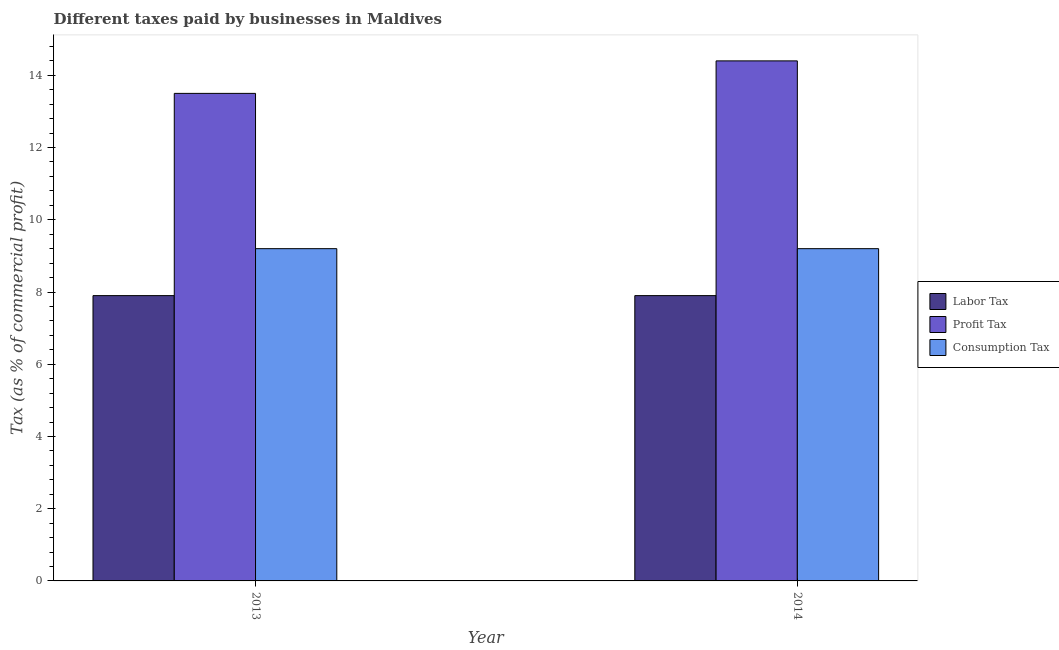How many groups of bars are there?
Your answer should be very brief. 2. How many bars are there on the 1st tick from the right?
Make the answer very short. 3. What is the label of the 2nd group of bars from the left?
Provide a short and direct response. 2014. In how many cases, is the number of bars for a given year not equal to the number of legend labels?
Provide a short and direct response. 0. What is the percentage of labor tax in 2013?
Give a very brief answer. 7.9. Across all years, what is the maximum percentage of consumption tax?
Your answer should be compact. 9.2. Across all years, what is the minimum percentage of consumption tax?
Keep it short and to the point. 9.2. In which year was the percentage of consumption tax maximum?
Offer a terse response. 2013. In which year was the percentage of labor tax minimum?
Keep it short and to the point. 2013. What is the difference between the percentage of profit tax in 2013 and that in 2014?
Offer a terse response. -0.9. What is the difference between the percentage of profit tax in 2014 and the percentage of consumption tax in 2013?
Your answer should be compact. 0.9. What is the average percentage of consumption tax per year?
Offer a very short reply. 9.2. In how many years, is the percentage of labor tax greater than 12.4 %?
Provide a short and direct response. 0. What is the ratio of the percentage of labor tax in 2013 to that in 2014?
Provide a succinct answer. 1. What does the 2nd bar from the left in 2014 represents?
Your response must be concise. Profit Tax. What does the 3rd bar from the right in 2013 represents?
Ensure brevity in your answer.  Labor Tax. Is it the case that in every year, the sum of the percentage of labor tax and percentage of profit tax is greater than the percentage of consumption tax?
Your response must be concise. Yes. Are all the bars in the graph horizontal?
Provide a short and direct response. No. How many years are there in the graph?
Provide a short and direct response. 2. Are the values on the major ticks of Y-axis written in scientific E-notation?
Keep it short and to the point. No. Does the graph contain grids?
Your answer should be compact. No. Where does the legend appear in the graph?
Keep it short and to the point. Center right. How many legend labels are there?
Give a very brief answer. 3. How are the legend labels stacked?
Your answer should be compact. Vertical. What is the title of the graph?
Your response must be concise. Different taxes paid by businesses in Maldives. Does "Labor Market" appear as one of the legend labels in the graph?
Provide a short and direct response. No. What is the label or title of the X-axis?
Your answer should be very brief. Year. What is the label or title of the Y-axis?
Provide a short and direct response. Tax (as % of commercial profit). What is the Tax (as % of commercial profit) in Profit Tax in 2013?
Your answer should be compact. 13.5. What is the Tax (as % of commercial profit) in Consumption Tax in 2013?
Your response must be concise. 9.2. What is the Tax (as % of commercial profit) of Labor Tax in 2014?
Your answer should be very brief. 7.9. What is the Tax (as % of commercial profit) in Profit Tax in 2014?
Your response must be concise. 14.4. What is the Tax (as % of commercial profit) of Consumption Tax in 2014?
Your answer should be very brief. 9.2. Across all years, what is the maximum Tax (as % of commercial profit) in Profit Tax?
Offer a terse response. 14.4. Across all years, what is the minimum Tax (as % of commercial profit) in Labor Tax?
Your answer should be very brief. 7.9. Across all years, what is the minimum Tax (as % of commercial profit) in Profit Tax?
Make the answer very short. 13.5. What is the total Tax (as % of commercial profit) in Labor Tax in the graph?
Your response must be concise. 15.8. What is the total Tax (as % of commercial profit) in Profit Tax in the graph?
Give a very brief answer. 27.9. What is the total Tax (as % of commercial profit) of Consumption Tax in the graph?
Your answer should be very brief. 18.4. What is the difference between the Tax (as % of commercial profit) in Profit Tax in 2013 and that in 2014?
Your answer should be very brief. -0.9. What is the difference between the Tax (as % of commercial profit) of Labor Tax in 2013 and the Tax (as % of commercial profit) of Profit Tax in 2014?
Offer a very short reply. -6.5. What is the difference between the Tax (as % of commercial profit) in Profit Tax in 2013 and the Tax (as % of commercial profit) in Consumption Tax in 2014?
Your answer should be compact. 4.3. What is the average Tax (as % of commercial profit) of Profit Tax per year?
Offer a very short reply. 13.95. In the year 2013, what is the difference between the Tax (as % of commercial profit) in Labor Tax and Tax (as % of commercial profit) in Profit Tax?
Keep it short and to the point. -5.6. In the year 2013, what is the difference between the Tax (as % of commercial profit) of Labor Tax and Tax (as % of commercial profit) of Consumption Tax?
Make the answer very short. -1.3. In the year 2013, what is the difference between the Tax (as % of commercial profit) in Profit Tax and Tax (as % of commercial profit) in Consumption Tax?
Your answer should be compact. 4.3. In the year 2014, what is the difference between the Tax (as % of commercial profit) in Labor Tax and Tax (as % of commercial profit) in Profit Tax?
Offer a terse response. -6.5. In the year 2014, what is the difference between the Tax (as % of commercial profit) of Labor Tax and Tax (as % of commercial profit) of Consumption Tax?
Give a very brief answer. -1.3. In the year 2014, what is the difference between the Tax (as % of commercial profit) in Profit Tax and Tax (as % of commercial profit) in Consumption Tax?
Provide a succinct answer. 5.2. What is the ratio of the Tax (as % of commercial profit) in Labor Tax in 2013 to that in 2014?
Provide a succinct answer. 1. What is the ratio of the Tax (as % of commercial profit) of Profit Tax in 2013 to that in 2014?
Offer a terse response. 0.94. What is the ratio of the Tax (as % of commercial profit) in Consumption Tax in 2013 to that in 2014?
Offer a very short reply. 1. What is the difference between the highest and the second highest Tax (as % of commercial profit) of Labor Tax?
Keep it short and to the point. 0. What is the difference between the highest and the second highest Tax (as % of commercial profit) in Profit Tax?
Your response must be concise. 0.9. What is the difference between the highest and the second highest Tax (as % of commercial profit) of Consumption Tax?
Your answer should be very brief. 0. What is the difference between the highest and the lowest Tax (as % of commercial profit) in Labor Tax?
Offer a very short reply. 0. 